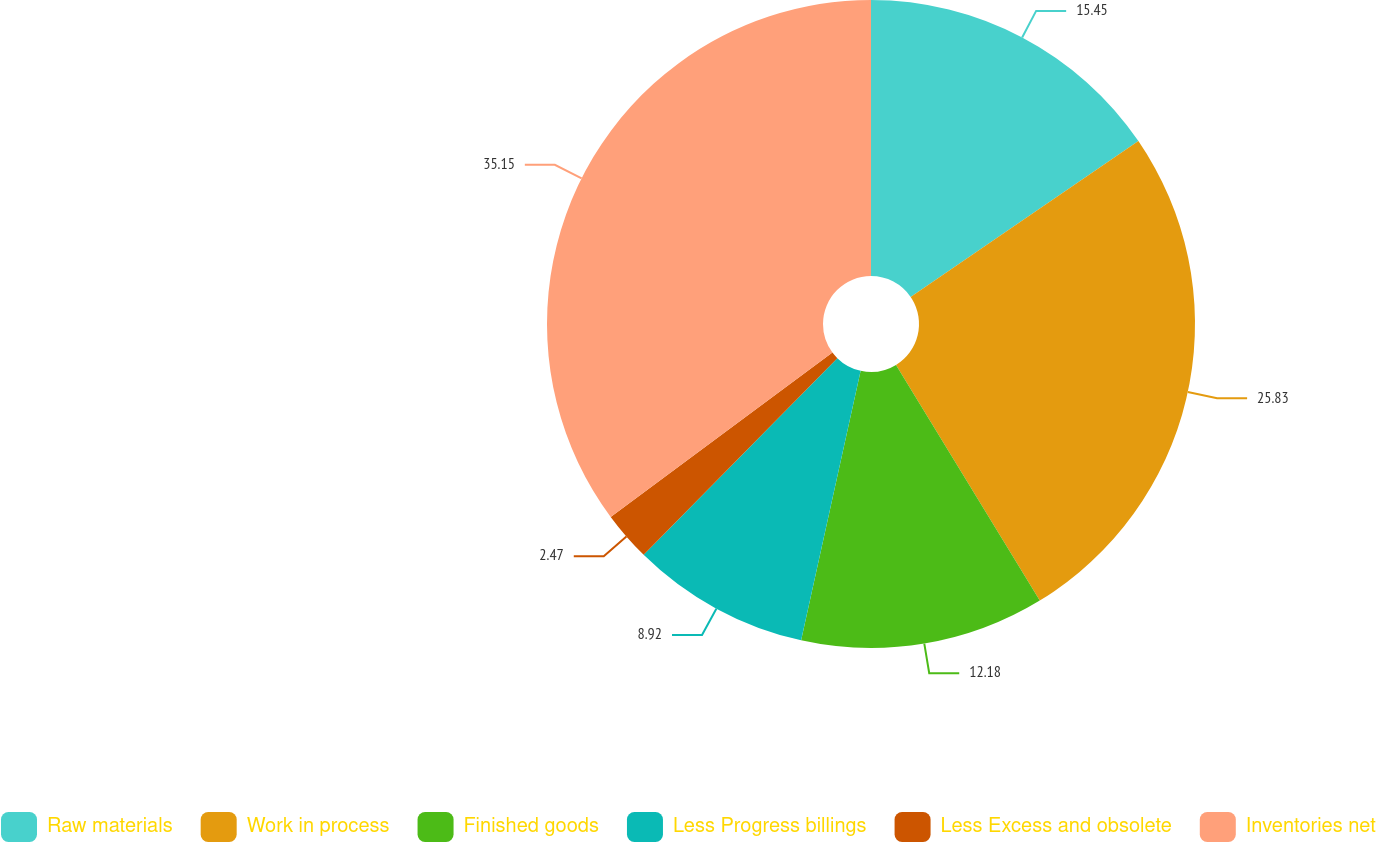Convert chart to OTSL. <chart><loc_0><loc_0><loc_500><loc_500><pie_chart><fcel>Raw materials<fcel>Work in process<fcel>Finished goods<fcel>Less Progress billings<fcel>Less Excess and obsolete<fcel>Inventories net<nl><fcel>15.45%<fcel>25.83%<fcel>12.18%<fcel>8.92%<fcel>2.47%<fcel>35.15%<nl></chart> 